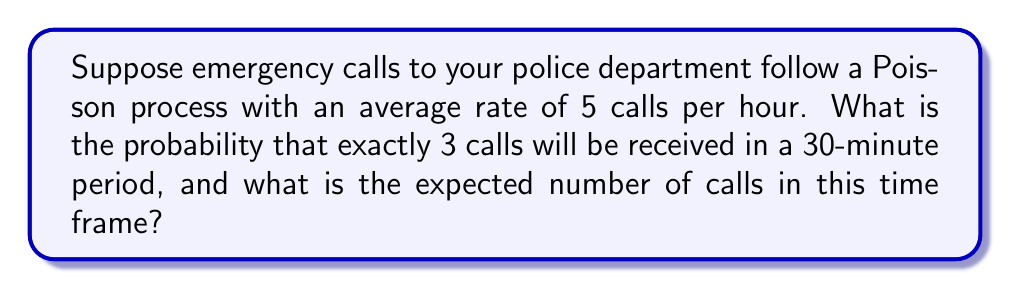Could you help me with this problem? Let's approach this step-by-step:

1) First, we need to adjust the rate for a 30-minute period. If λ = 5 calls/hour, then for 30 minutes:
   λ_30min = 5 * (30/60) = 2.5 calls per 30 minutes

2) For a Poisson process, the probability of exactly k events in a time interval t is given by:

   $$P(X = k) = \frac{e^{-λt}(λt)^k}{k!}$$

3) In this case, we want P(X = 3) with λt = 2.5:

   $$P(X = 3) = \frac{e^{-2.5}(2.5)^3}{3!}$$

4) Calculating this:
   $$P(X = 3) = \frac{e^{-2.5} * 15.625}{6} \approx 0.1577$$

5) For the expected number of calls, in a Poisson process, the expected value is equal to λt:

   E(X) = λt = 2.5

Thus, the probability of exactly 3 calls in 30 minutes is approximately 0.1577 or 15.77%, and the expected number of calls in 30 minutes is 2.5.
Answer: P(X = 3) ≈ 0.1577, E(X) = 2.5 